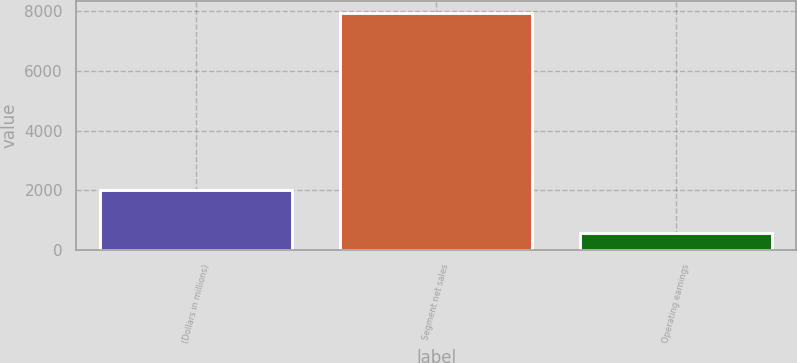Convert chart. <chart><loc_0><loc_0><loc_500><loc_500><bar_chart><fcel>(Dollars in millions)<fcel>Segment net sales<fcel>Operating earnings<nl><fcel>2009<fcel>7963<fcel>558<nl></chart> 